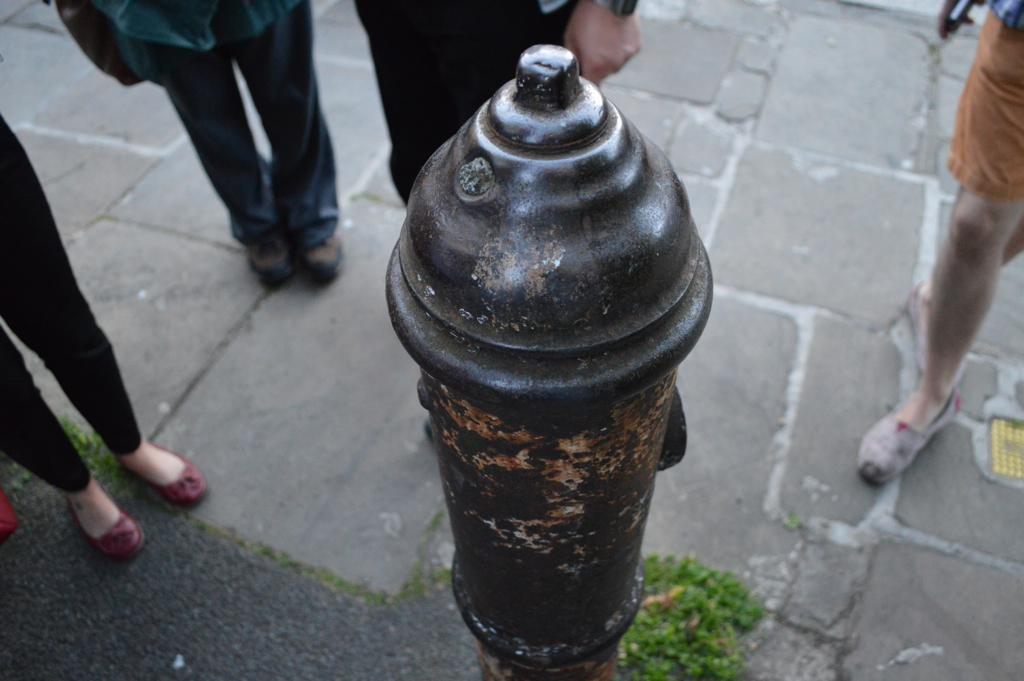In one or two sentences, can you explain what this image depicts? As we can see in the image there is a water pipe and few people standing in the front. 